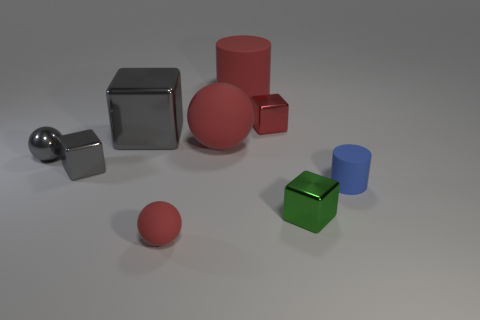Add 1 gray shiny cubes. How many objects exist? 10 Subtract all spheres. How many objects are left? 6 Add 1 large gray metal cylinders. How many large gray metal cylinders exist? 1 Subtract 0 brown cylinders. How many objects are left? 9 Subtract all big cyan spheres. Subtract all red objects. How many objects are left? 5 Add 7 tiny gray things. How many tiny gray things are left? 9 